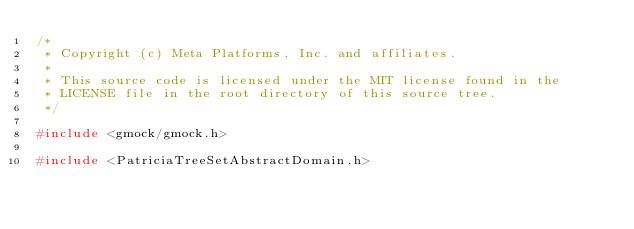<code> <loc_0><loc_0><loc_500><loc_500><_C++_>/*
 * Copyright (c) Meta Platforms, Inc. and affiliates.
 *
 * This source code is licensed under the MIT license found in the
 * LICENSE file in the root directory of this source tree.
 */

#include <gmock/gmock.h>

#include <PatriciaTreeSetAbstractDomain.h></code> 